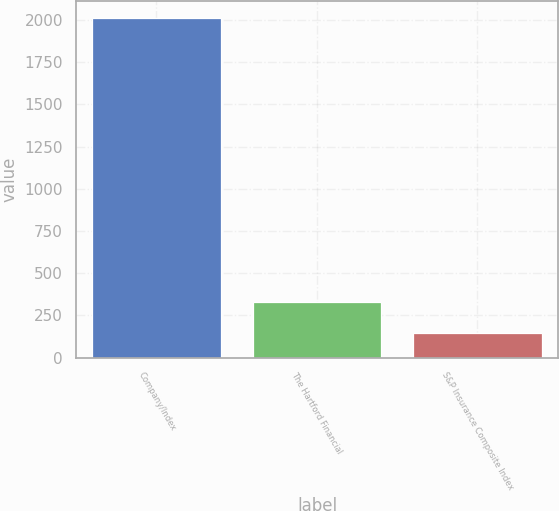<chart> <loc_0><loc_0><loc_500><loc_500><bar_chart><fcel>Company/Index<fcel>The Hartford Financial<fcel>S&P Insurance Composite Index<nl><fcel>2012<fcel>330.86<fcel>144.07<nl></chart> 